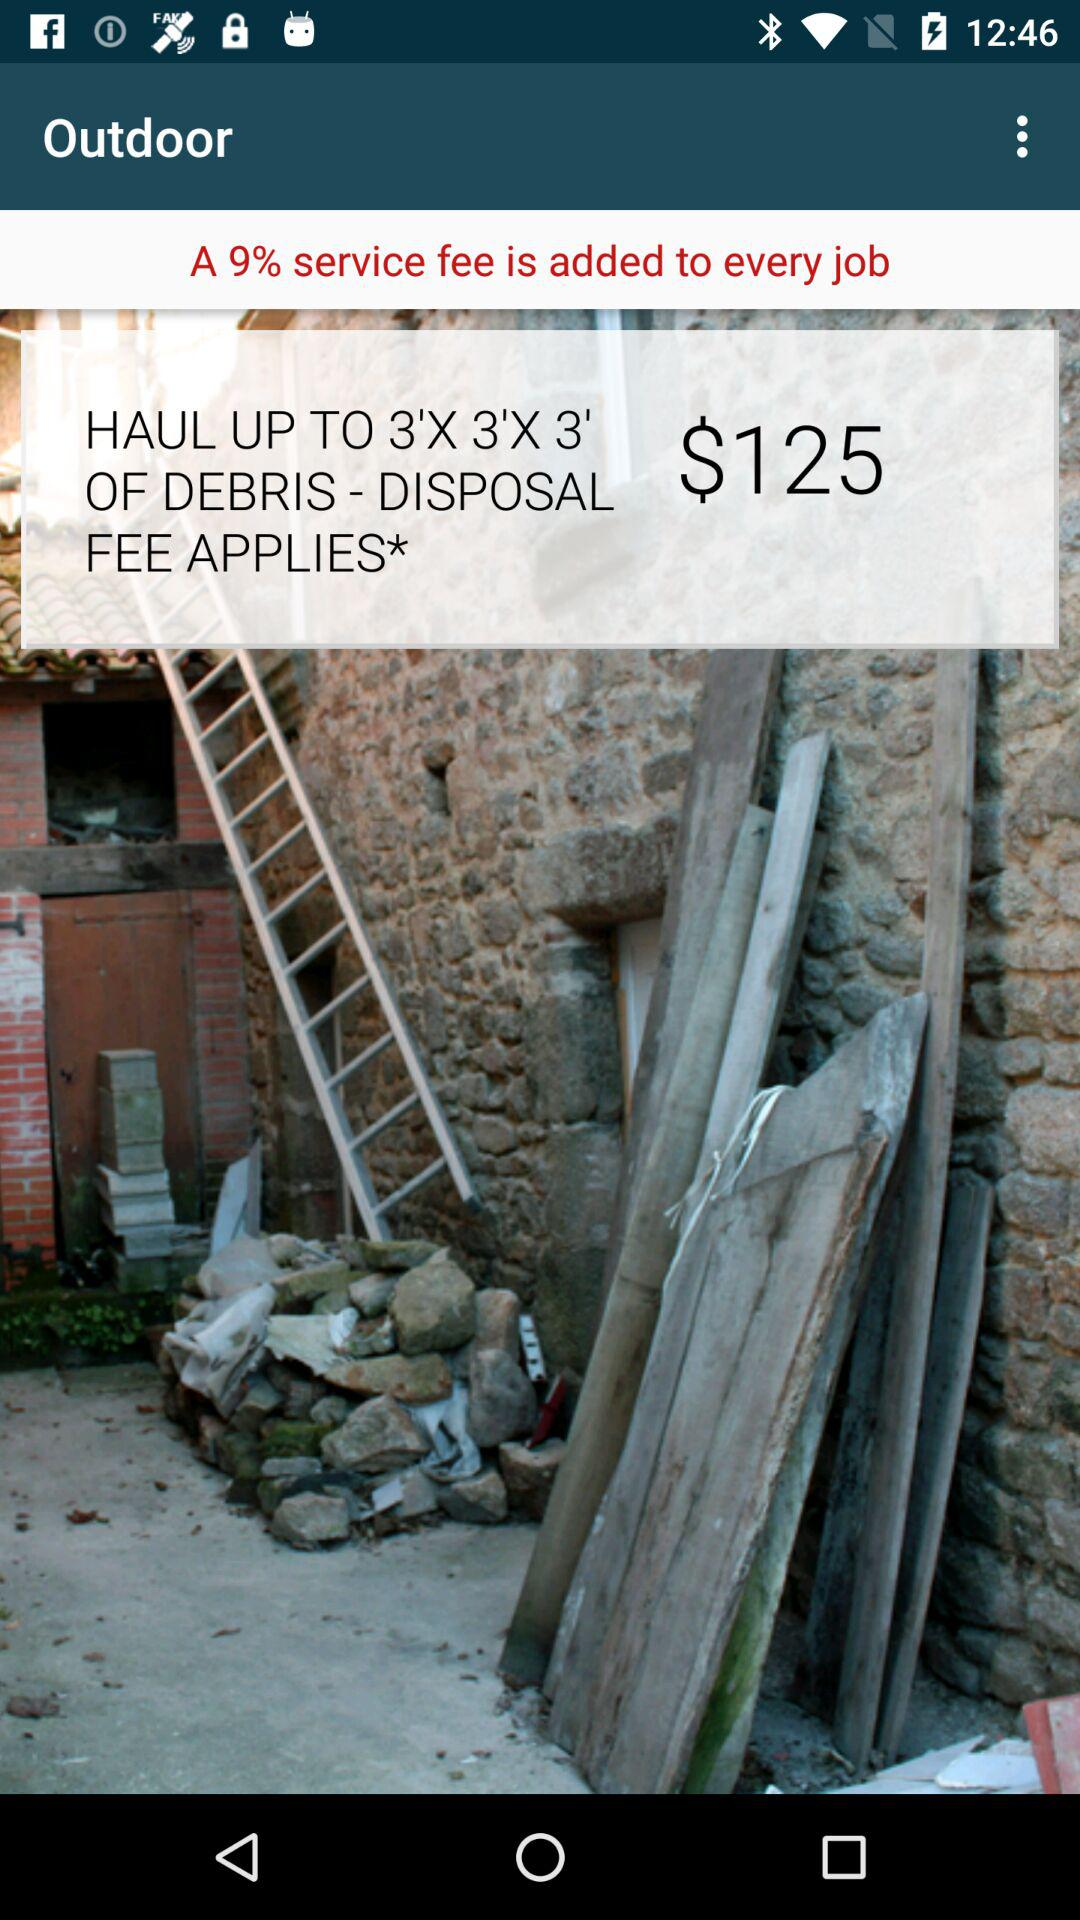How much is the disposal fee for the job?
Answer the question using a single word or phrase. $125 